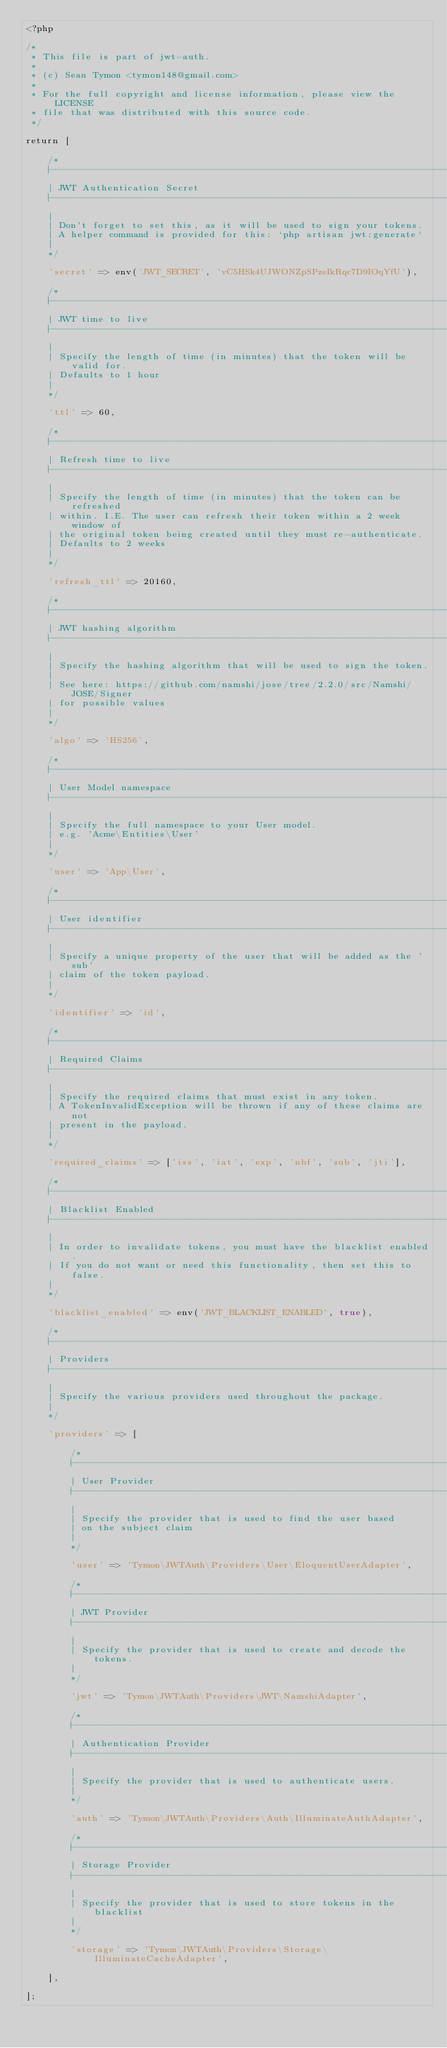<code> <loc_0><loc_0><loc_500><loc_500><_PHP_><?php

/*
 * This file is part of jwt-auth.
 *
 * (c) Sean Tymon <tymon148@gmail.com>
 *
 * For the full copyright and license information, please view the LICENSE
 * file that was distributed with this source code.
 */

return [

    /*
    |--------------------------------------------------------------------------
    | JWT Authentication Secret
    |--------------------------------------------------------------------------
    |
    | Don't forget to set this, as it will be used to sign your tokens.
    | A helper command is provided for this: `php artisan jwt:generate`
    |
    */

    'secret' => env('JWT_SECRET', 'vC5HSk4UJWONZpSPzeIkRqc7D9IOqYfU'),

    /*
    |--------------------------------------------------------------------------
    | JWT time to live
    |--------------------------------------------------------------------------
    |
    | Specify the length of time (in minutes) that the token will be valid for.
    | Defaults to 1 hour
    |
    */

    'ttl' => 60,

    /*
    |--------------------------------------------------------------------------
    | Refresh time to live
    |--------------------------------------------------------------------------
    |
    | Specify the length of time (in minutes) that the token can be refreshed
    | within. I.E. The user can refresh their token within a 2 week window of
    | the original token being created until they must re-authenticate.
    | Defaults to 2 weeks
    |
    */

    'refresh_ttl' => 20160,

    /*
    |--------------------------------------------------------------------------
    | JWT hashing algorithm
    |--------------------------------------------------------------------------
    |
    | Specify the hashing algorithm that will be used to sign the token.
    |
    | See here: https://github.com/namshi/jose/tree/2.2.0/src/Namshi/JOSE/Signer
    | for possible values
    |
    */

    'algo' => 'HS256',

    /*
    |--------------------------------------------------------------------------
    | User Model namespace
    |--------------------------------------------------------------------------
    |
    | Specify the full namespace to your User model.
    | e.g. 'Acme\Entities\User'
    |
    */

    'user' => 'App\User',

    /*
    |--------------------------------------------------------------------------
    | User identifier
    |--------------------------------------------------------------------------
    |
    | Specify a unique property of the user that will be added as the 'sub'
    | claim of the token payload.
    |
    */

    'identifier' => 'id',

    /*
    |--------------------------------------------------------------------------
    | Required Claims
    |--------------------------------------------------------------------------
    |
    | Specify the required claims that must exist in any token.
    | A TokenInvalidException will be thrown if any of these claims are not
    | present in the payload.
    |
    */

    'required_claims' => ['iss', 'iat', 'exp', 'nbf', 'sub', 'jti'],

    /*
    |--------------------------------------------------------------------------
    | Blacklist Enabled
    |--------------------------------------------------------------------------
    |
    | In order to invalidate tokens, you must have the blacklist enabled.
    | If you do not want or need this functionality, then set this to false.
    |
    */

    'blacklist_enabled' => env('JWT_BLACKLIST_ENABLED', true),

    /*
    |--------------------------------------------------------------------------
    | Providers
    |--------------------------------------------------------------------------
    |
    | Specify the various providers used throughout the package.
    |
    */

    'providers' => [

        /*
        |--------------------------------------------------------------------------
        | User Provider
        |--------------------------------------------------------------------------
        |
        | Specify the provider that is used to find the user based
        | on the subject claim
        |
        */

        'user' => 'Tymon\JWTAuth\Providers\User\EloquentUserAdapter',

        /*
        |--------------------------------------------------------------------------
        | JWT Provider
        |--------------------------------------------------------------------------
        |
        | Specify the provider that is used to create and decode the tokens.
        |
        */

        'jwt' => 'Tymon\JWTAuth\Providers\JWT\NamshiAdapter',

        /*
        |--------------------------------------------------------------------------
        | Authentication Provider
        |--------------------------------------------------------------------------
        |
        | Specify the provider that is used to authenticate users.
        |
        */

        'auth' => 'Tymon\JWTAuth\Providers\Auth\IlluminateAuthAdapter',

        /*
        |--------------------------------------------------------------------------
        | Storage Provider
        |--------------------------------------------------------------------------
        |
        | Specify the provider that is used to store tokens in the blacklist
        |
        */

        'storage' => 'Tymon\JWTAuth\Providers\Storage\IlluminateCacheAdapter',

    ],

];
</code> 